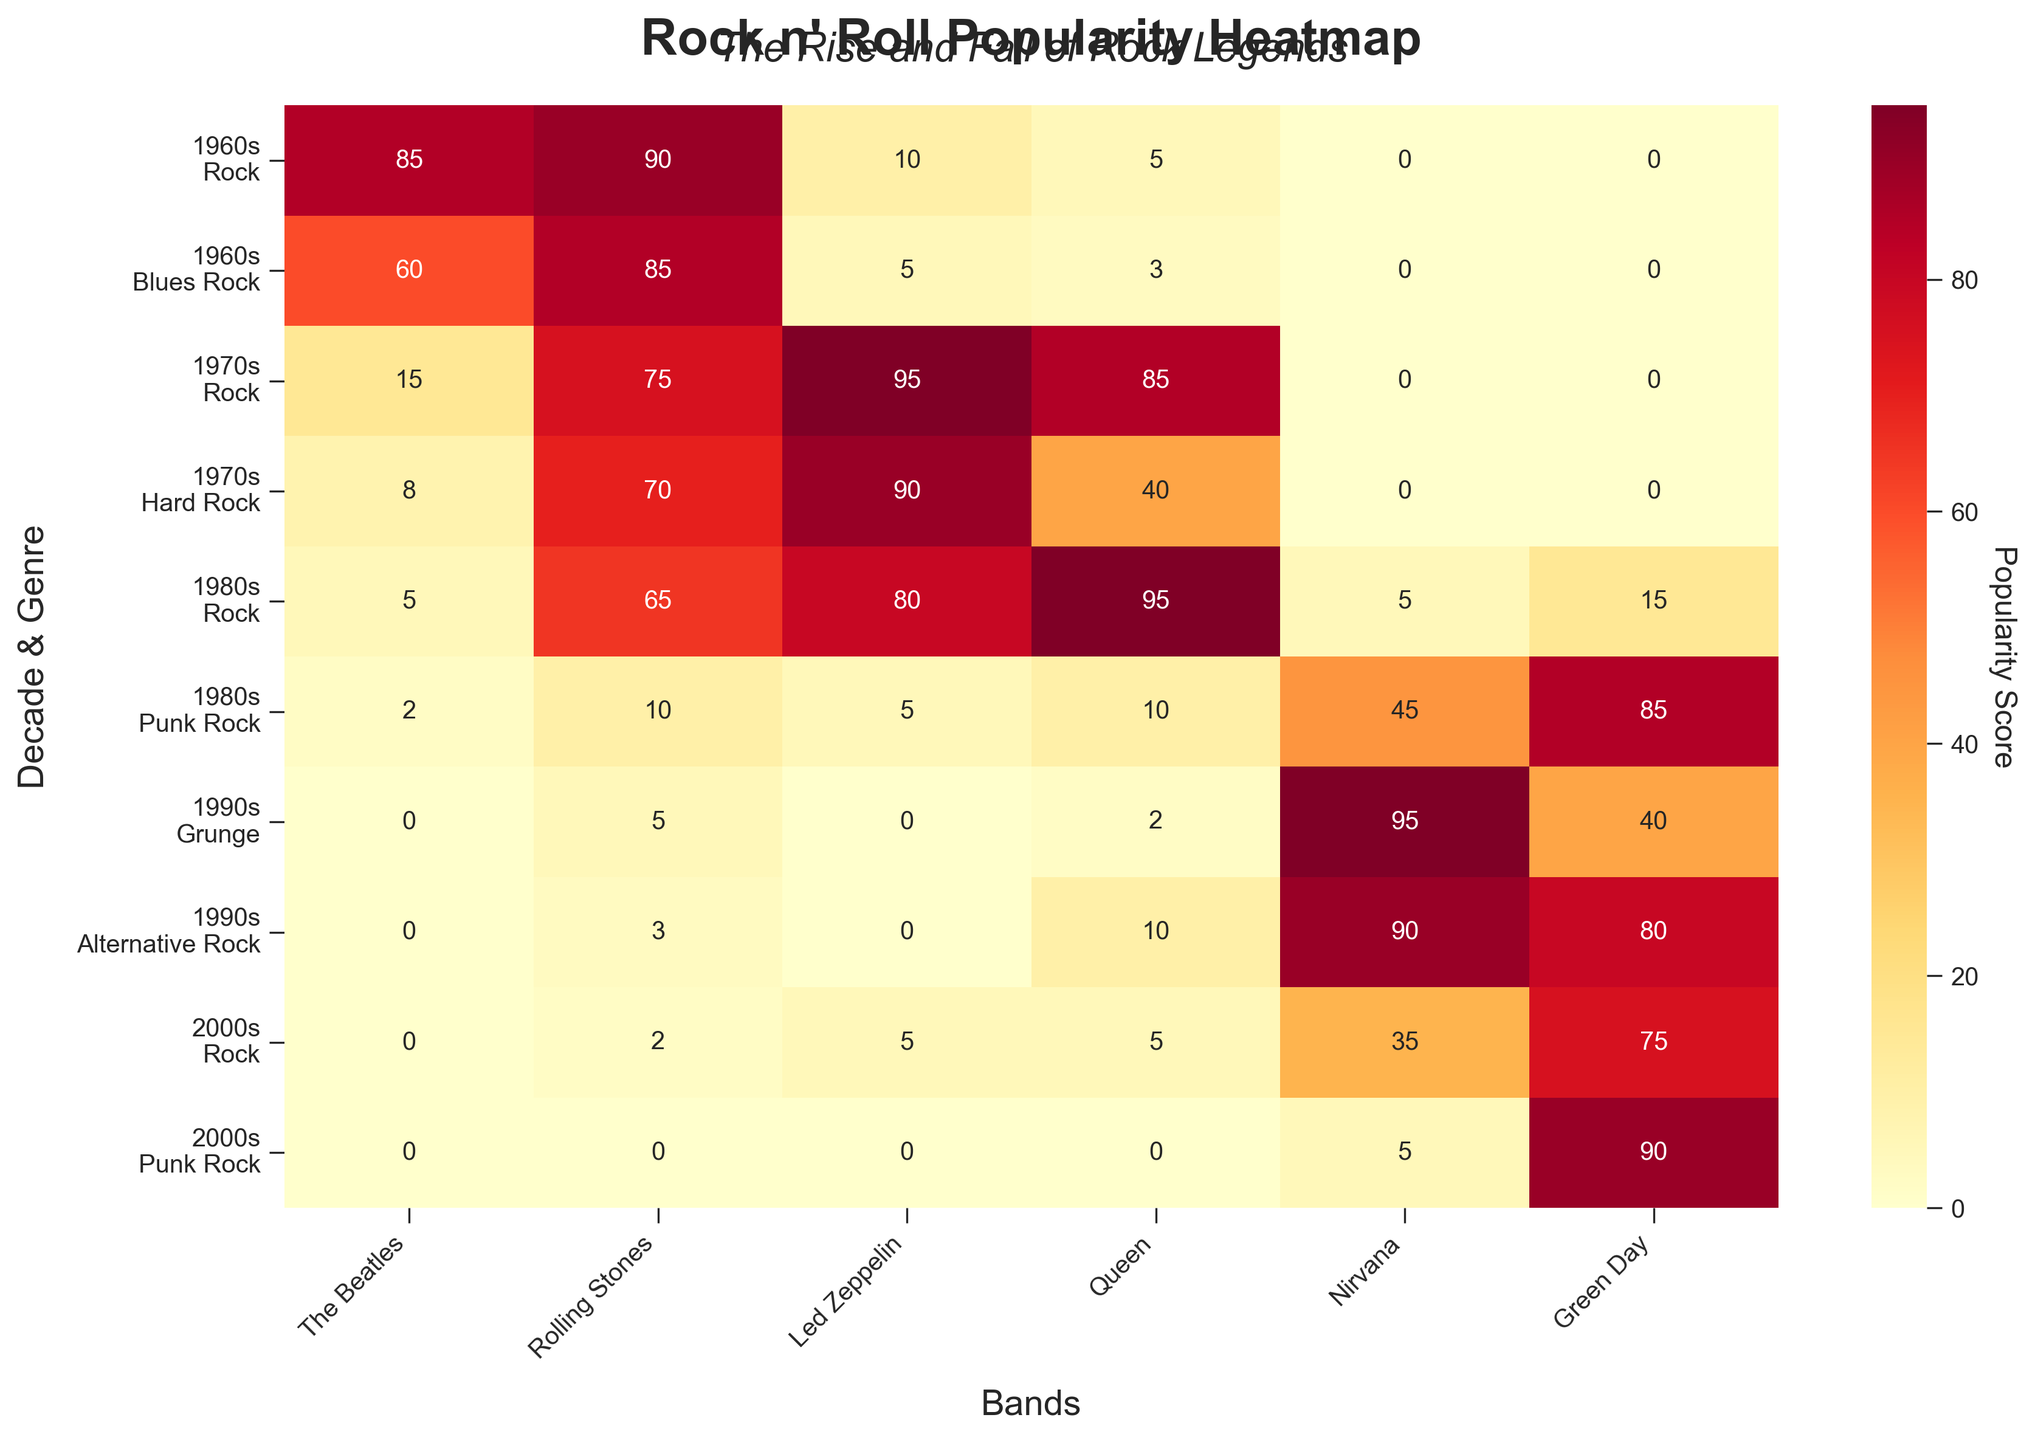What is the highest popularity score achieved by The Beatles? The highest popularity score achieved by The Beatles can be directly observed from the heatmap at the intersection where the value is highest. Here, The Beatles have a highest score of 85 in the 1960s Rock genre.
Answer: 85 Which decade and genre have the highest popularity for the Rolling Stones? To find this, look at the heatmap and locate the highest value in the Rolling Stones column. The highest score for the Rolling Stones is 90 in the 1960s Rock genre.
Answer: 1960s Rock How do the popularity scores of Nirvana in Grunge compare to those in Alternative Rock in the 1990s? Check the heatmap for Nirvana scores in both genres for the 1990s. In Grunge, Nirvana has a score of 95, whereas in Alternative Rock, the score is 90.
Answer: Grunge: 95, Alternative Rock: 90 What's the average popularity score for Green Day across all decades and genres combined? Extract Green Day's scores from each cell (0, 0, 0, 10, 45, 85, 40, 80, 75, 90) and sum these scores. Then, divide by the total number of data points (10). The sum is 425 and the average is 425/10.
Answer: 42.5 Which band had the highest popularity score in the 1980s Punk Rock genre? Look at the values under the 1980s Punk Rock row and identify the highest score among all bands. Green Day has the highest value with 85.
Answer: Green Day Is the popularity score of Led Zeppelin in the 1980s Rock genre higher or lower than their score in the 1970s Rock genre? Compare the scores of Led Zeppelin in both genres. In the 1980s Rock, the score is 80. In the 1970s Rock, the score is 95.
Answer: Lower How did Queen's popularity score change from the 1970s Rock to the 1980s Rock genre? Identify Queen's scores in both genres from the heatmap. In 1970s Rock, Queen scored 85 and in 1980s Rock, the score increased to 95. The change is 95 - 85.
Answer: Increased by 10 What is the combined popularity score of The Beatles and Rolling Stones in the 1960s Blues Rock genre? Add together the popularity scores of both bands in the specified genre. The Beatles have a score of 60 and Rolling Stones have 85 in the 1960s Blues Rock. The sum is 60 + 85.
Answer: 145 In which decade and genre did Nirvana achieve their highest popularity score? Check the heatmap to find the highest score for Nirvana across all decades and genres. Nirvana's highest popularity score (95) is in the 1990s Grunge genre.
Answer: 1990s Grunge What's the difference between the popularity scores of Rolling Stones in the 1960s Rock and 2000s Rock genres? Find both popularity scores on the heatmap (90 in 1960s Rock and 2 in 2000s Rock). Calculate the difference: 90 - 2.
Answer: 88 